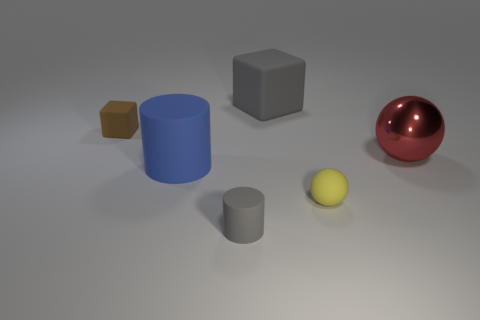Add 1 big rubber cubes. How many objects exist? 7 Subtract all red spheres. How many spheres are left? 1 Subtract 1 cylinders. How many cylinders are left? 1 Subtract all spheres. How many objects are left? 4 Add 2 big red things. How many big red things are left? 3 Add 5 small cyan shiny cylinders. How many small cyan shiny cylinders exist? 5 Subtract 0 brown spheres. How many objects are left? 6 Subtract all red cubes. Subtract all blue cylinders. How many cubes are left? 2 Subtract all small red shiny cubes. Subtract all blue rubber cylinders. How many objects are left? 5 